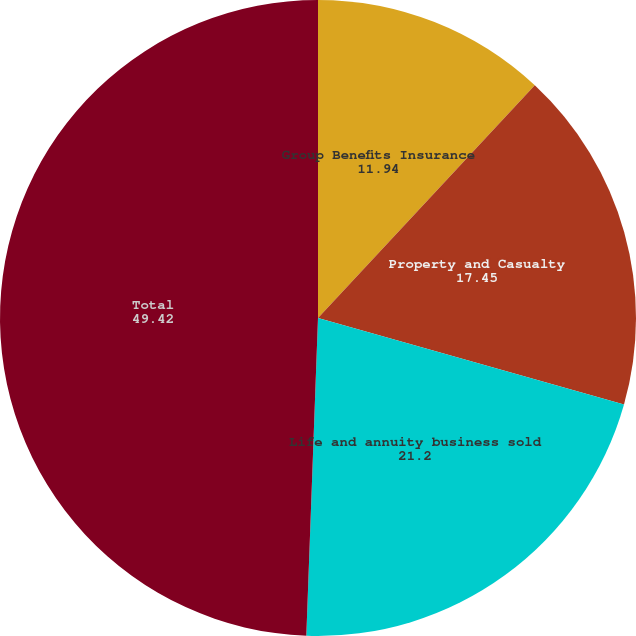<chart> <loc_0><loc_0><loc_500><loc_500><pie_chart><fcel>Group Benefits Insurance<fcel>Property and Casualty<fcel>Life and annuity business sold<fcel>Total<nl><fcel>11.94%<fcel>17.45%<fcel>21.2%<fcel>49.42%<nl></chart> 